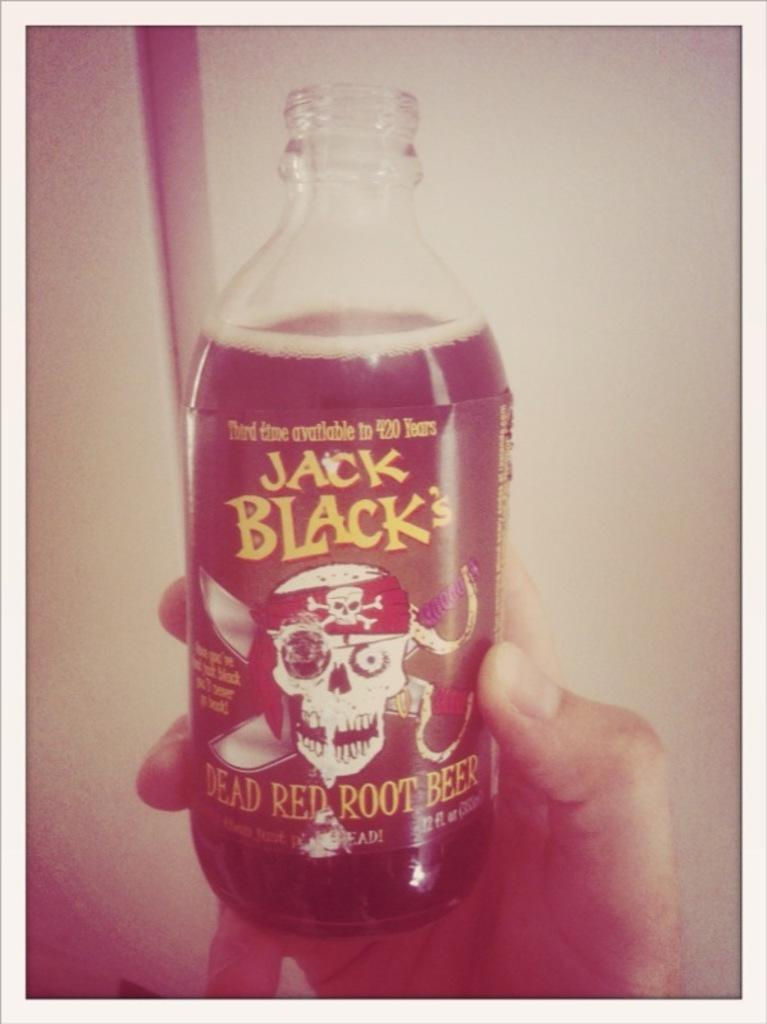<image>
Give a short and clear explanation of the subsequent image. a bottle of Jack Black's Dead Red Root Beer 